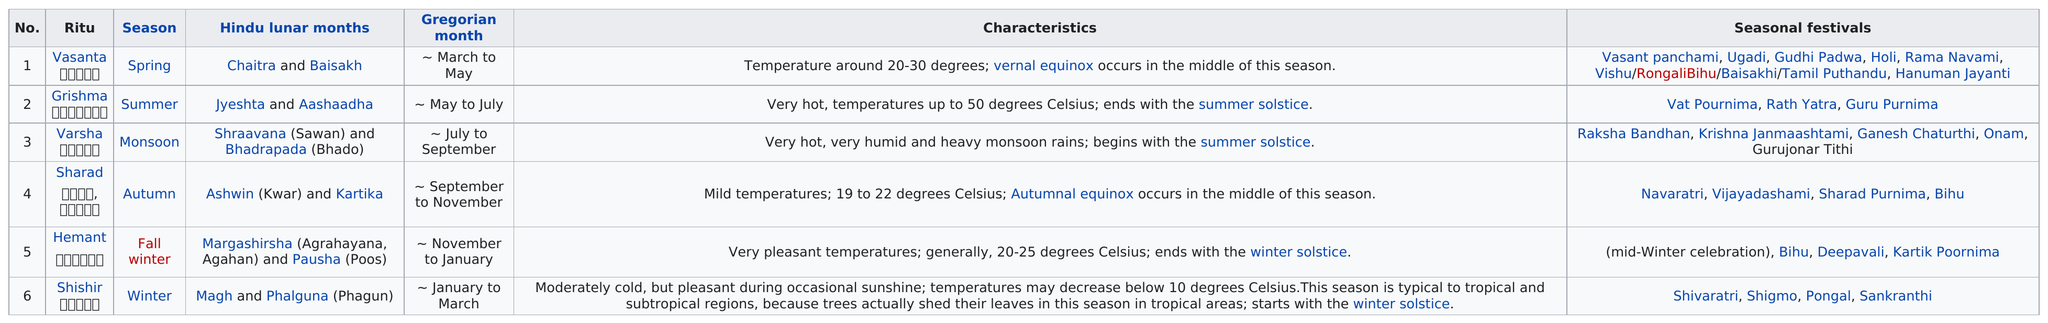Highlight a few significant elements in this photo. Vasanta Ritu is the season that has the most seasonal festivals. Grishma lasts from May to July 